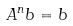<formula> <loc_0><loc_0><loc_500><loc_500>A ^ { n } b = b</formula> 